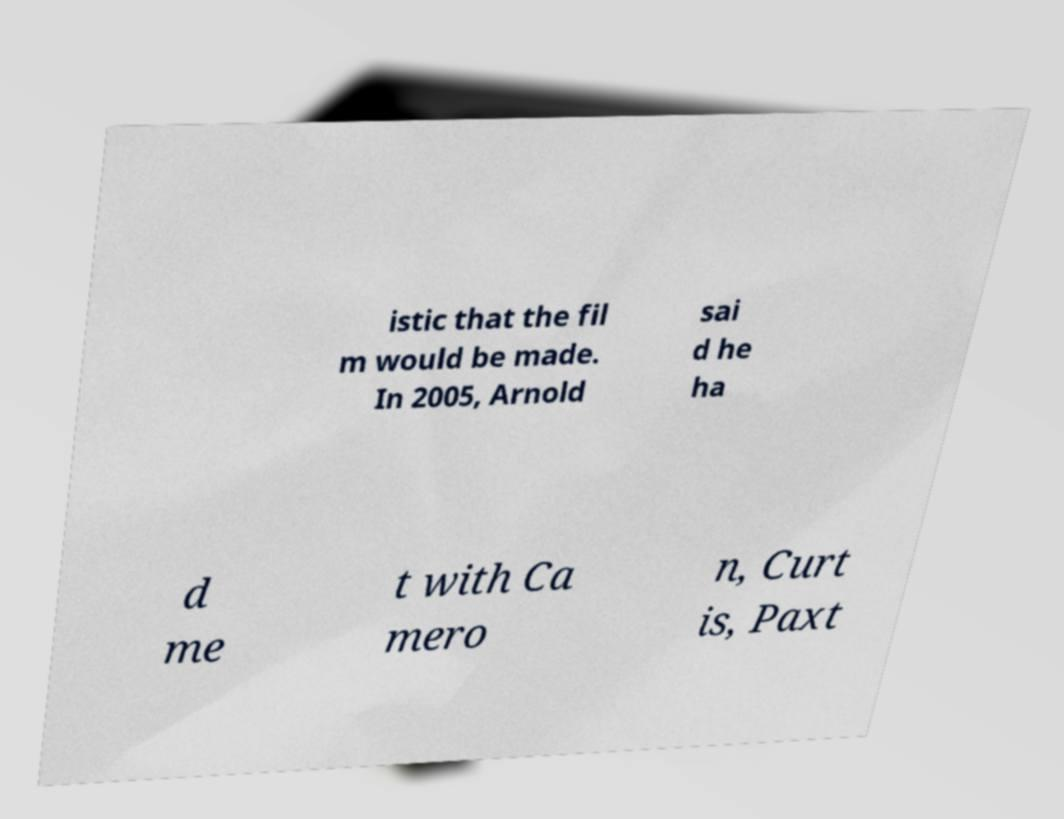There's text embedded in this image that I need extracted. Can you transcribe it verbatim? istic that the fil m would be made. In 2005, Arnold sai d he ha d me t with Ca mero n, Curt is, Paxt 